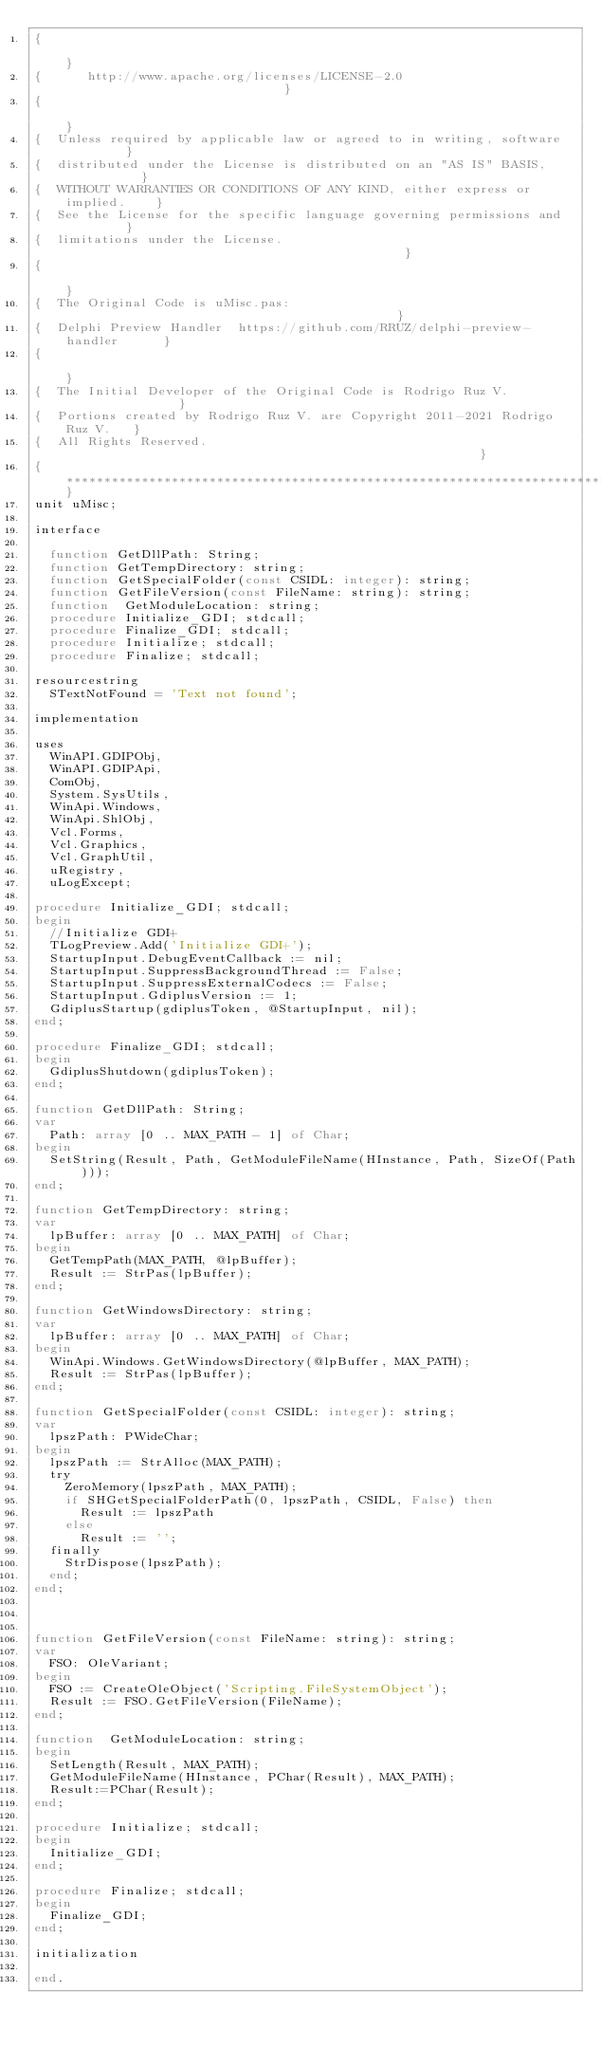Convert code to text. <code><loc_0><loc_0><loc_500><loc_500><_Pascal_>{                                                                              }
{      http://www.apache.org/licenses/LICENSE-2.0                              }
{                                                                              }
{  Unless required by applicable law or agreed to in writing, software         }
{  distributed under the License is distributed on an "AS IS" BASIS,           }
{  WITHOUT WARRANTIES OR CONDITIONS OF ANY KIND, either express or implied.    }
{  See the License for the specific language governing permissions and         }
{  limitations under the License.                                              }
{                                                                              }
{  The Original Code is uMisc.pas:                                             }
{  Delphi Preview Handler  https://github.com/RRUZ/delphi-preview-handler      }
{                                                                              }
{  The Initial Developer of the Original Code is Rodrigo Ruz V.                }
{  Portions created by Rodrigo Ruz V. are Copyright 2011-2021 Rodrigo Ruz V.   }
{  All Rights Reserved.                                                        }
{******************************************************************************}
unit uMisc;

interface

  function GetDllPath: String;
  function GetTempDirectory: string;
  function GetSpecialFolder(const CSIDL: integer): string;
  function GetFileVersion(const FileName: string): string;
  function  GetModuleLocation: string;
  procedure Initialize_GDI; stdcall;
  procedure Finalize_GDI; stdcall;
  procedure Initialize; stdcall;
  procedure Finalize; stdcall;

resourcestring
  STextNotFound = 'Text not found';

implementation

uses
  WinAPI.GDIPObj,
  WinAPI.GDIPApi,
  ComObj,
  System.SysUtils,
  WinApi.Windows,
  WinApi.ShlObj,
  Vcl.Forms,
  Vcl.Graphics,
  Vcl.GraphUtil,
  uRegistry,
  uLogExcept;

procedure Initialize_GDI; stdcall;
begin
  //Initialize GDI+
  TLogPreview.Add('Initialize GDI+');
  StartupInput.DebugEventCallback := nil;
  StartupInput.SuppressBackgroundThread := False;
  StartupInput.SuppressExternalCodecs := False;
  StartupInput.GdiplusVersion := 1;
  GdiplusStartup(gdiplusToken, @StartupInput, nil);
end;

procedure Finalize_GDI; stdcall;
begin
  GdiplusShutdown(gdiplusToken);
end;

function GetDllPath: String;
var
  Path: array [0 .. MAX_PATH - 1] of Char;
begin
  SetString(Result, Path, GetModuleFileName(HInstance, Path, SizeOf(Path)));
end;

function GetTempDirectory: string;
var
  lpBuffer: array [0 .. MAX_PATH] of Char;
begin
  GetTempPath(MAX_PATH, @lpBuffer);
  Result := StrPas(lpBuffer);
end;

function GetWindowsDirectory: string;
var
  lpBuffer: array [0 .. MAX_PATH] of Char;
begin
  WinApi.Windows.GetWindowsDirectory(@lpBuffer, MAX_PATH);
  Result := StrPas(lpBuffer);
end;

function GetSpecialFolder(const CSIDL: integer): string;
var
  lpszPath: PWideChar;
begin
  lpszPath := StrAlloc(MAX_PATH);
  try
    ZeroMemory(lpszPath, MAX_PATH);
    if SHGetSpecialFolderPath(0, lpszPath, CSIDL, False) then
      Result := lpszPath
    else
      Result := '';
  finally
    StrDispose(lpszPath);
  end;
end;



function GetFileVersion(const FileName: string): string;
var
  FSO: OleVariant;
begin
  FSO := CreateOleObject('Scripting.FileSystemObject');
  Result := FSO.GetFileVersion(FileName);
end;

function  GetModuleLocation: string;
begin
  SetLength(Result, MAX_PATH);
  GetModuleFileName(HInstance, PChar(Result), MAX_PATH);
  Result:=PChar(Result);
end;

procedure Initialize; stdcall;
begin
  Initialize_GDI;
end;

procedure Finalize; stdcall;
begin
  Finalize_GDI;
end;

initialization

end.
</code> 